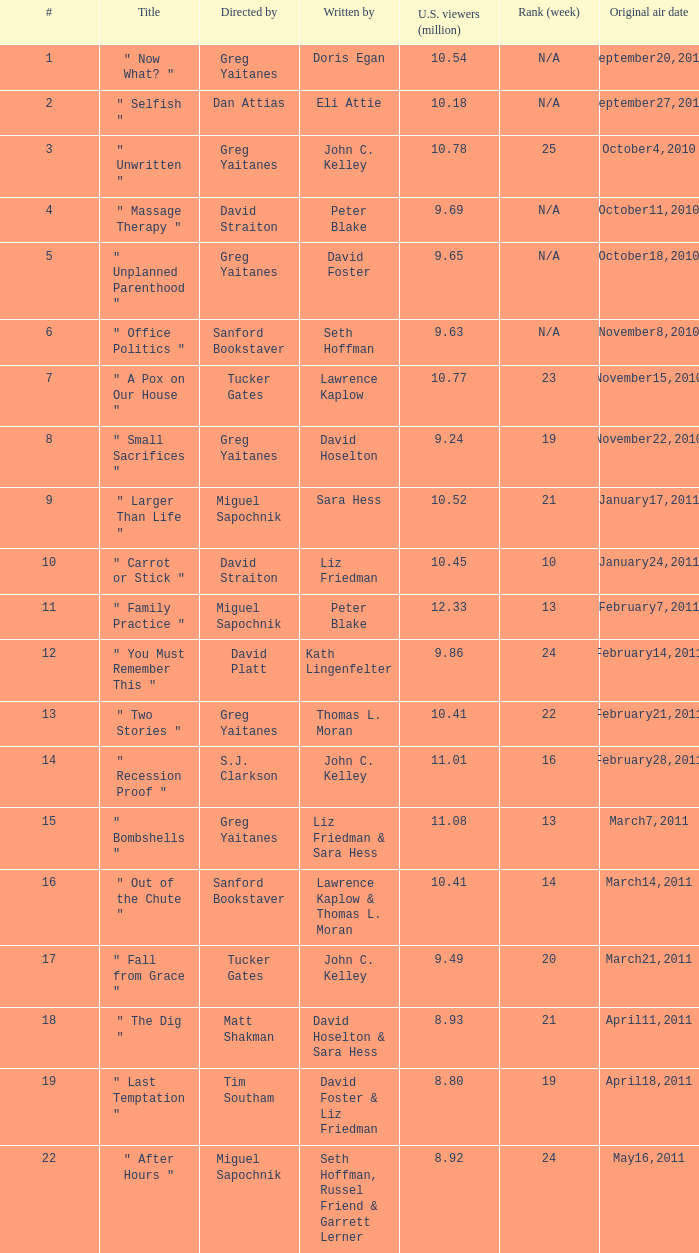Where did the episode rank that was written by thomas l. moran? 22.0. 